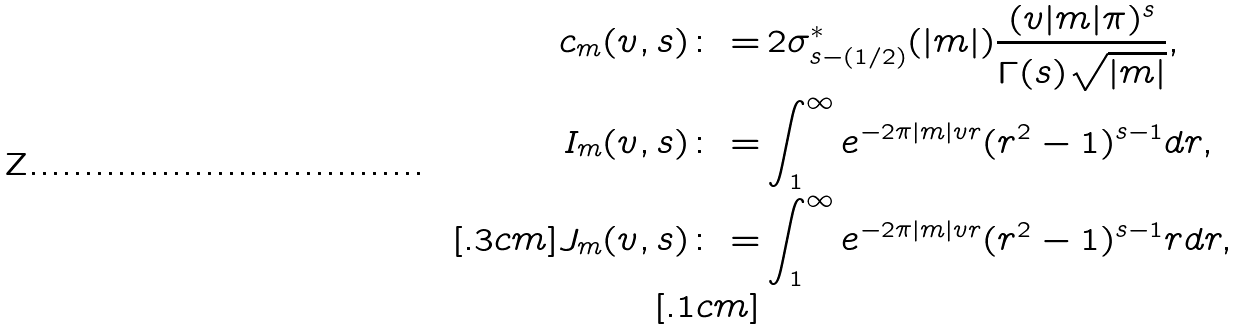<formula> <loc_0><loc_0><loc_500><loc_500>c _ { m } ( v , s ) \colon = & \, 2 \sigma ^ { \ast } _ { s - ( 1 / 2 ) } ( | m | ) \frac { ( v | m | \pi ) ^ { s } } { \Gamma ( s ) \sqrt { | m | } } , \\ I _ { m } ( v , s ) \colon = & \int _ { 1 } ^ { \infty } e ^ { - 2 \pi | m | v r } ( r ^ { 2 } - 1 ) ^ { s - 1 } d r , \\ [ . 3 c m ] J _ { m } ( v , s ) \colon = & \int _ { 1 } ^ { \infty } e ^ { - 2 \pi | m | v r } ( r ^ { 2 } - 1 ) ^ { s - 1 } r d r , \\ [ . 1 c m ]</formula> 